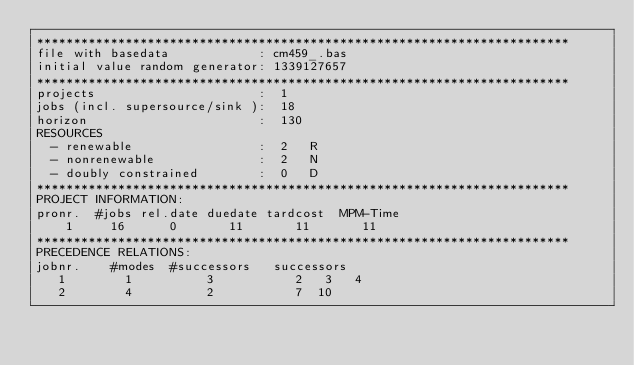Convert code to text. <code><loc_0><loc_0><loc_500><loc_500><_ObjectiveC_>************************************************************************
file with basedata            : cm459_.bas
initial value random generator: 1339127657
************************************************************************
projects                      :  1
jobs (incl. supersource/sink ):  18
horizon                       :  130
RESOURCES
  - renewable                 :  2   R
  - nonrenewable              :  2   N
  - doubly constrained        :  0   D
************************************************************************
PROJECT INFORMATION:
pronr.  #jobs rel.date duedate tardcost  MPM-Time
    1     16      0       11       11       11
************************************************************************
PRECEDENCE RELATIONS:
jobnr.    #modes  #successors   successors
   1        1          3           2   3   4
   2        4          2           7  10</code> 